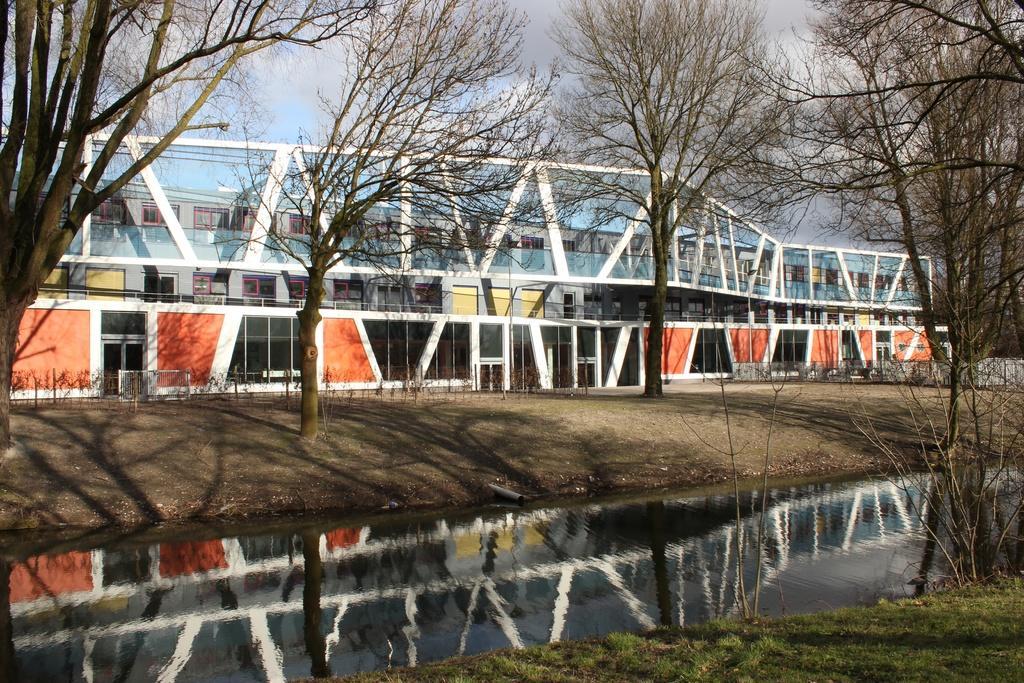Could you give a brief overview of what you see in this image? In the foreground of the picture I can see the lake. I can see the deciduous trees and green grass on the side of the lake. In the background, I can see the glass building. There are clouds in the sky. 